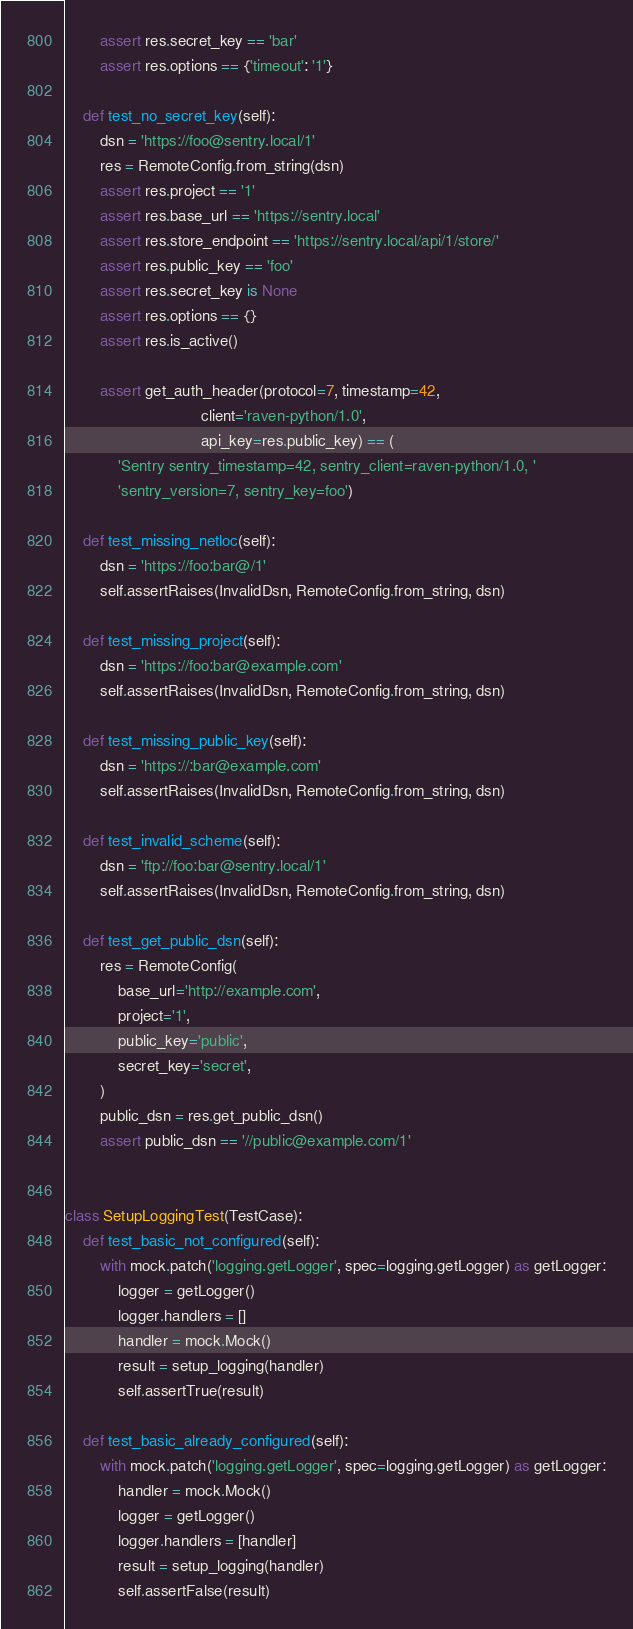Convert code to text. <code><loc_0><loc_0><loc_500><loc_500><_Python_>        assert res.secret_key == 'bar'
        assert res.options == {'timeout': '1'}

    def test_no_secret_key(self):
        dsn = 'https://foo@sentry.local/1'
        res = RemoteConfig.from_string(dsn)
        assert res.project == '1'
        assert res.base_url == 'https://sentry.local'
        assert res.store_endpoint == 'https://sentry.local/api/1/store/'
        assert res.public_key == 'foo'
        assert res.secret_key is None
        assert res.options == {}
        assert res.is_active()

        assert get_auth_header(protocol=7, timestamp=42,
                               client='raven-python/1.0',
                               api_key=res.public_key) == (
            'Sentry sentry_timestamp=42, sentry_client=raven-python/1.0, '
            'sentry_version=7, sentry_key=foo')

    def test_missing_netloc(self):
        dsn = 'https://foo:bar@/1'
        self.assertRaises(InvalidDsn, RemoteConfig.from_string, dsn)

    def test_missing_project(self):
        dsn = 'https://foo:bar@example.com'
        self.assertRaises(InvalidDsn, RemoteConfig.from_string, dsn)

    def test_missing_public_key(self):
        dsn = 'https://:bar@example.com'
        self.assertRaises(InvalidDsn, RemoteConfig.from_string, dsn)

    def test_invalid_scheme(self):
        dsn = 'ftp://foo:bar@sentry.local/1'
        self.assertRaises(InvalidDsn, RemoteConfig.from_string, dsn)

    def test_get_public_dsn(self):
        res = RemoteConfig(
            base_url='http://example.com',
            project='1',
            public_key='public',
            secret_key='secret',
        )
        public_dsn = res.get_public_dsn()
        assert public_dsn == '//public@example.com/1'


class SetupLoggingTest(TestCase):
    def test_basic_not_configured(self):
        with mock.patch('logging.getLogger', spec=logging.getLogger) as getLogger:
            logger = getLogger()
            logger.handlers = []
            handler = mock.Mock()
            result = setup_logging(handler)
            self.assertTrue(result)

    def test_basic_already_configured(self):
        with mock.patch('logging.getLogger', spec=logging.getLogger) as getLogger:
            handler = mock.Mock()
            logger = getLogger()
            logger.handlers = [handler]
            result = setup_logging(handler)
            self.assertFalse(result)
</code> 